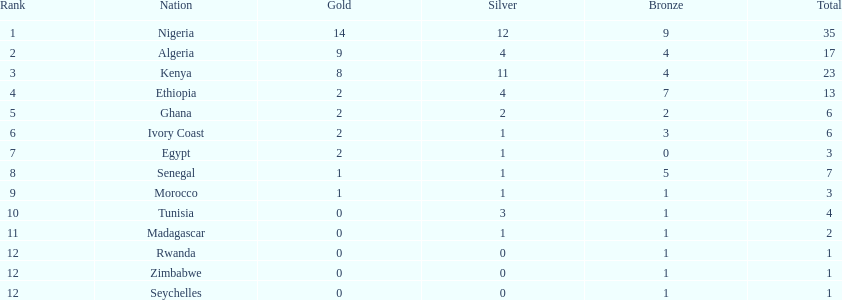What was the total number of medals the ivory coast won? 6. 